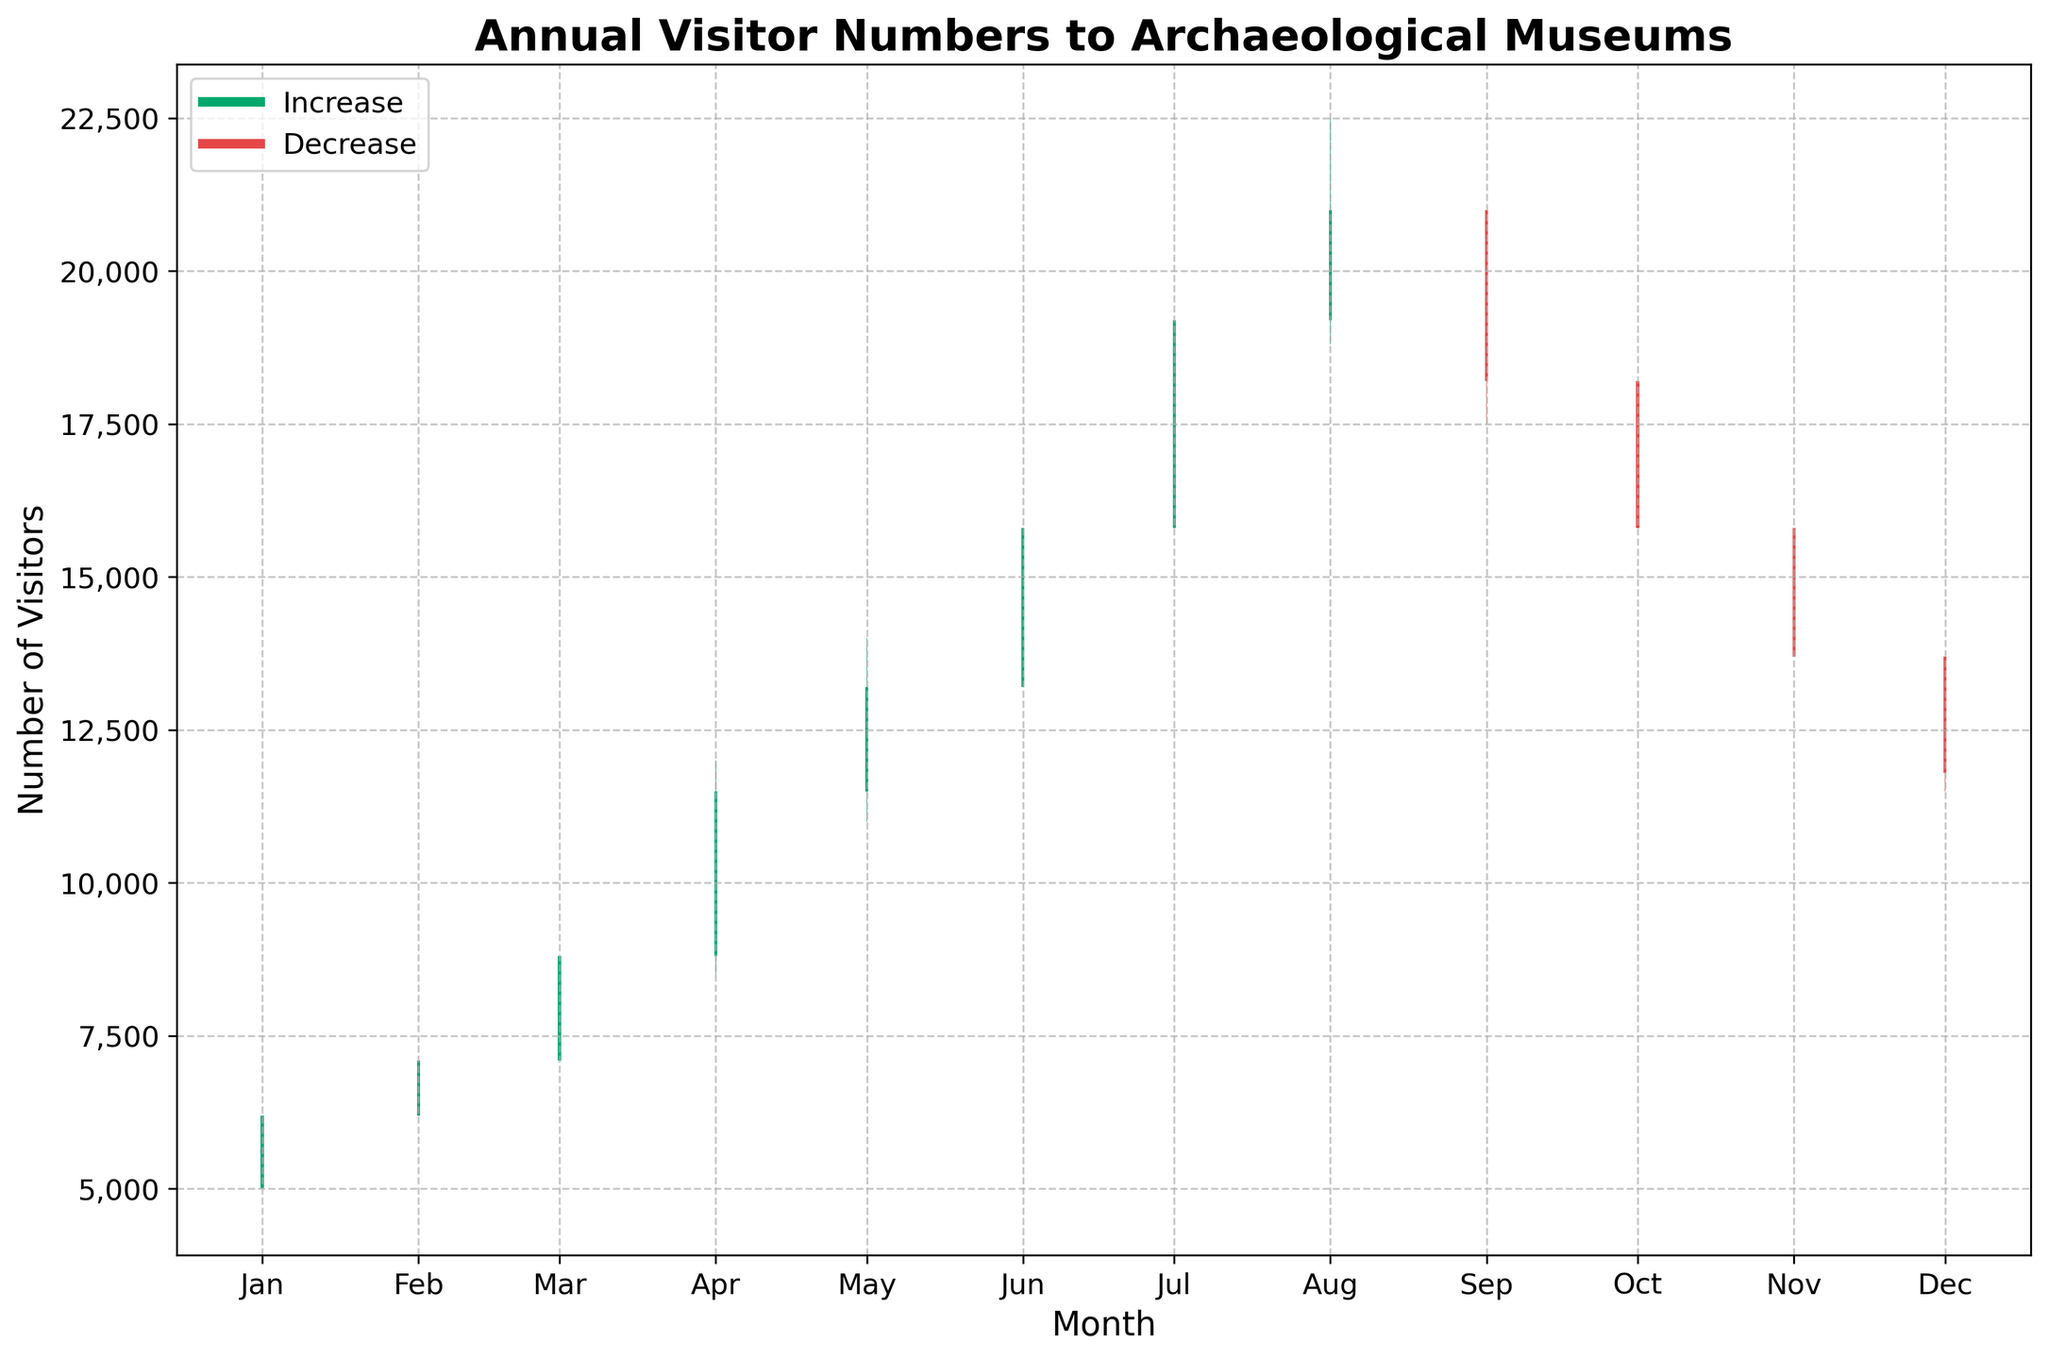what is the title of the plot? The title is displayed at the top of the plot, indicating the main subject of the chart: "Annual Visitor Numbers to Archaeological Museums".
Answer: Annual Visitor Numbers to Archaeological Museums what colors are used to represent increases and decreases in visitor numbers? The plot uses green for increases and red for decreases. These colors can be observed in the bars of the OHLC chart.
Answer: Green for increases, red for decreases how does visitor attendance in October compare to that in September? In October, the visitor numbers decreased from September. This can be noted from the red bar for October and observing the closing value which is lower in October compared to September's closing value.
Answer: October has fewer visitors than September what month had the highest peak attendance? The month with the highest peak attendance can be identified by finding the largest value on the y-axis, which is in July. The peak attendance is represented by the highest point in the bars on the chart.
Answer: July what is the difference in visitor numbers between May's closing and November's closing? To find the difference, subtract November's closing value from May's closing value. May closed at 13,200 and November closed at 13,700, so the difference is 13,200 - 13,700.
Answer: -500 which months had more visitors at closing than opening? To determine this, we need to check the months where close values are greater than open values, distinguishable by the green bars on the chart. These months are January, February, March, April, May, June, July, and August.
Answer: January, February, March, April, May, June, July, August during which months did visitor numbers decrease from opening to closing? The months where close values are less than open values are shown by red bars. The months with a decrease from opening to closing are September, October, November, and December.
Answer: September, October, November, December calculate the average visitor number for the opening values in the last three months of the year (October, November, December). Sum the opening values for October, November, and December, and then divide by 3. The opening values are 18,200 for October, 15,800 for November, and 13,700 for December, so the average is (18,200 + 15,800 + 13,700) / 3.
Answer: 15,900 what can you infer about seasonal variations in visitor numbers? Observing the peaks and troughs throughout the year, the numbers peak during summer months (June to August) and taper off towards the end of the year and the start of the year, indicating higher visitor numbers during the warmer months.
Answer: Higher in summer, lower at year start/end 